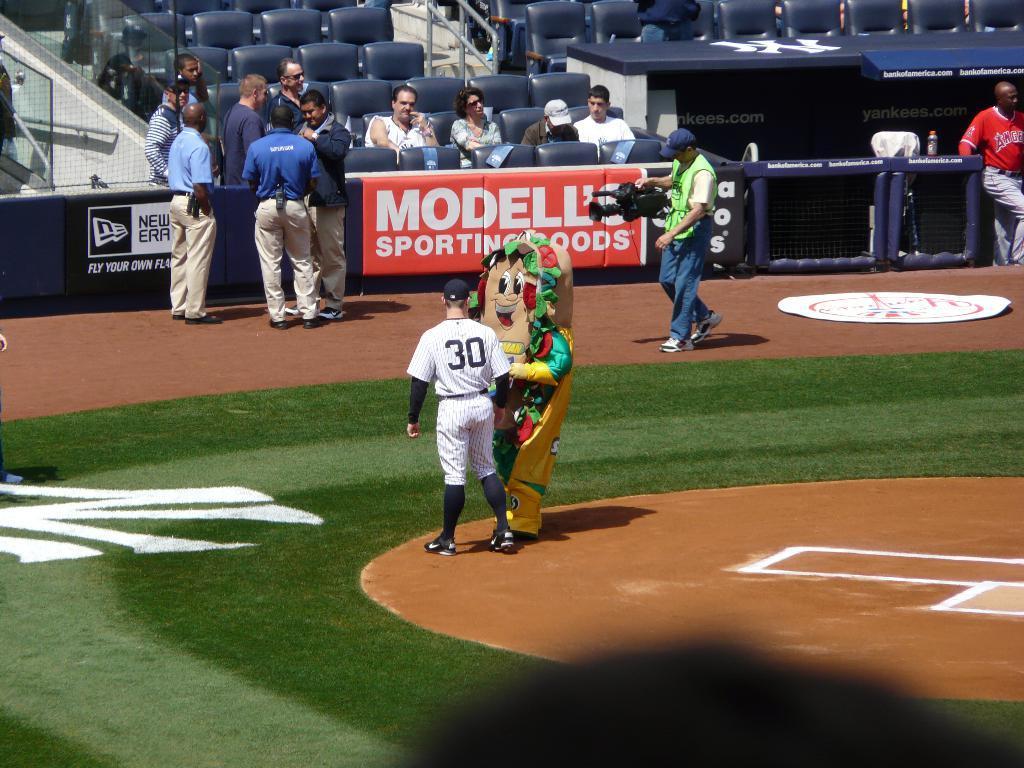How would you summarize this image in a sentence or two? In this image I see the ground on which there are few people in which this man is holding a camera and this person is wearing a costume and I see the green grass and in the background I see number of chairs on which there are few people sitting and I see something is written over here. 